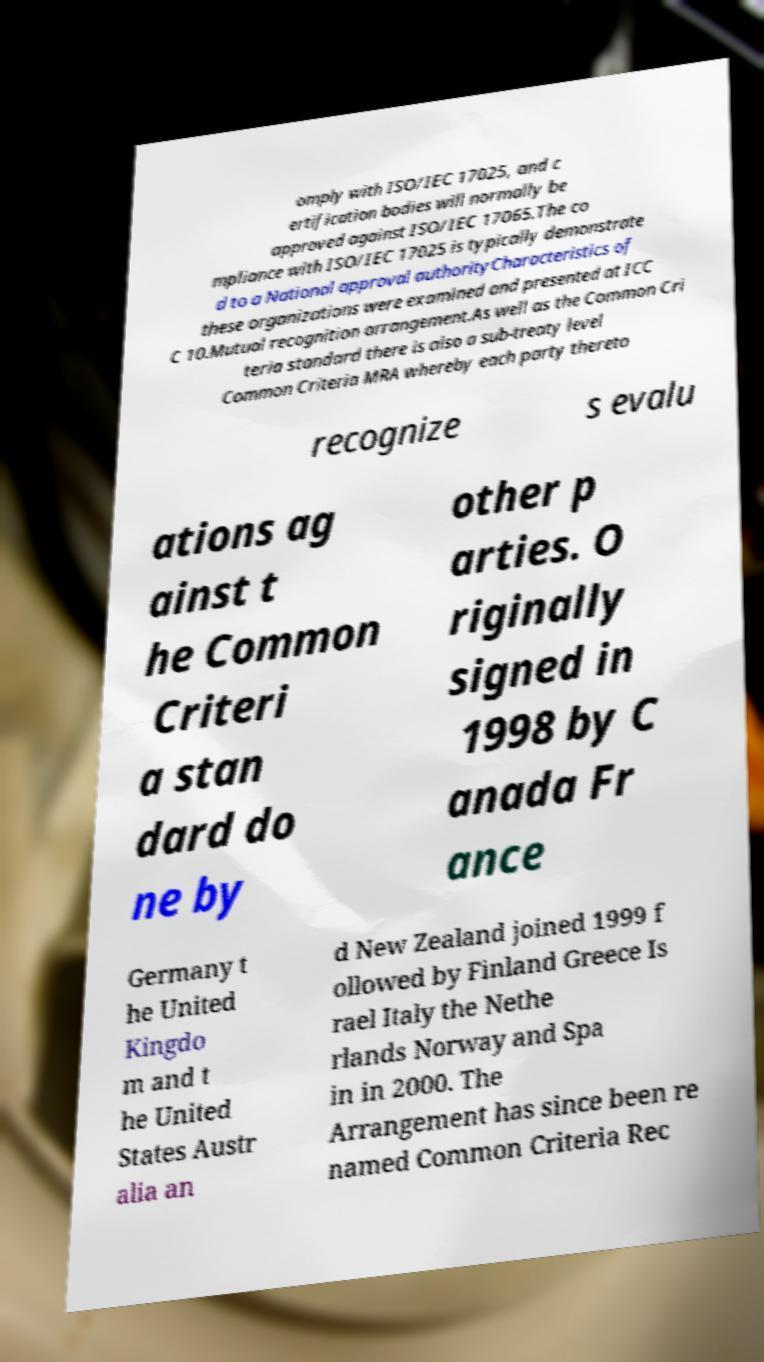What messages or text are displayed in this image? I need them in a readable, typed format. omply with ISO/IEC 17025, and c ertification bodies will normally be approved against ISO/IEC 17065.The co mpliance with ISO/IEC 17025 is typically demonstrate d to a National approval authorityCharacteristics of these organizations were examined and presented at ICC C 10.Mutual recognition arrangement.As well as the Common Cri teria standard there is also a sub-treaty level Common Criteria MRA whereby each party thereto recognize s evalu ations ag ainst t he Common Criteri a stan dard do ne by other p arties. O riginally signed in 1998 by C anada Fr ance Germany t he United Kingdo m and t he United States Austr alia an d New Zealand joined 1999 f ollowed by Finland Greece Is rael Italy the Nethe rlands Norway and Spa in in 2000. The Arrangement has since been re named Common Criteria Rec 